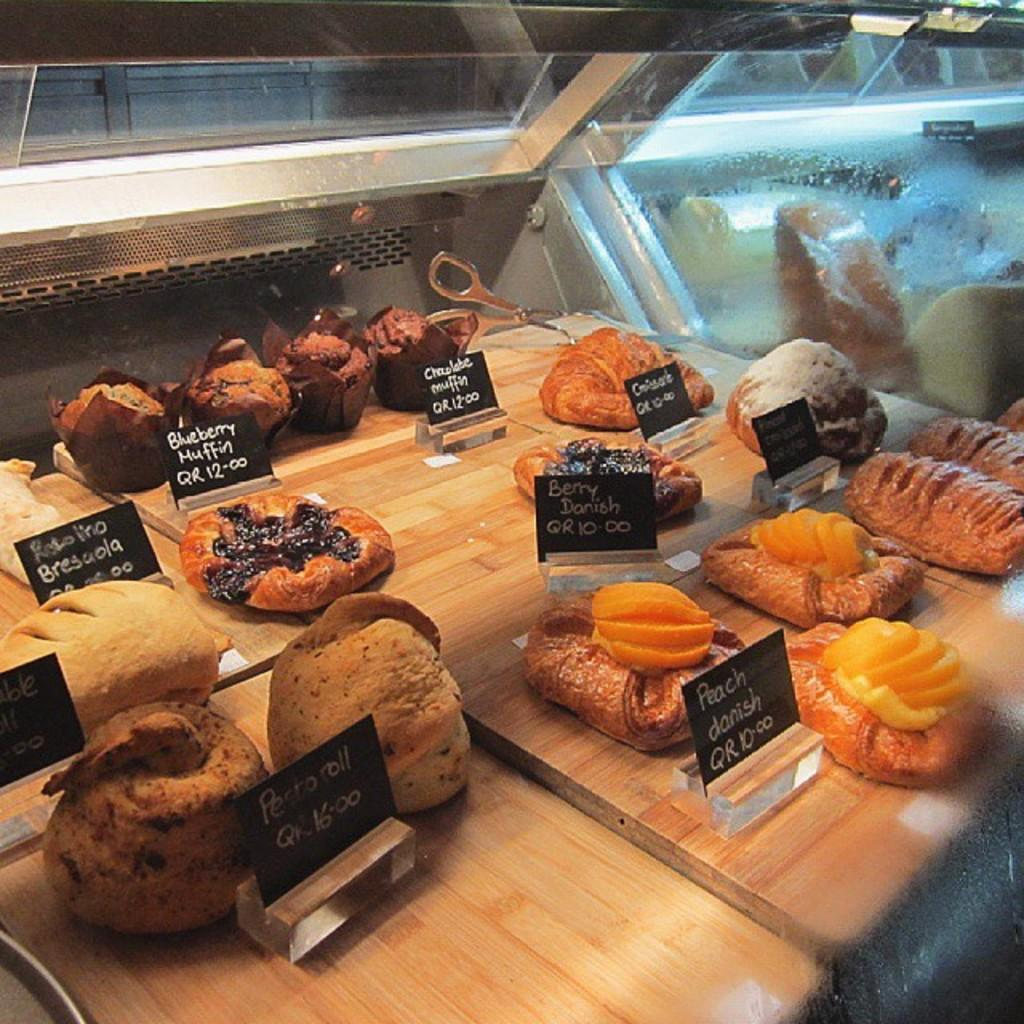What type of food items can be seen in the image? There are pastry items in the image. Where are the pastry items located? The pastry items are in a display box. How many jellyfish are swimming in the display box with the pastry items? There are no jellyfish present in the image; it only features pastry items in a display box. 